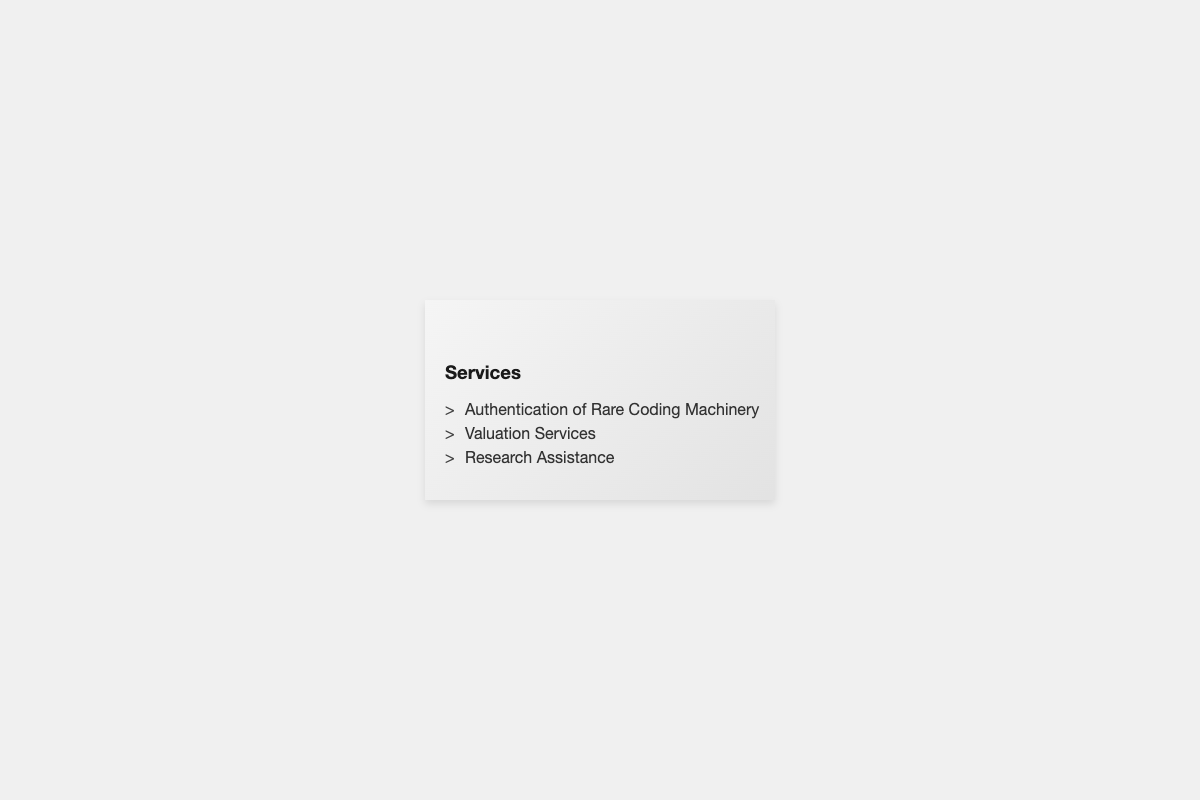What is the name of the specialist? The document provides the name "Alexis Morgan" as the tech historian and authentication specialist.
Answer: Alexis Morgan What services are offered? The front side of the business card lists three services: authentication of rare coding machinery, valuation services, and research assistance.
Answer: Authentication of Rare Coding Machinery, Valuation Services, Research Assistance What is the email address? The contact information on the back includes the email address for reaching Alexis Morgan, which is displayed.
Answer: amorgan@retrotechauthentica.com What is the contact phone number? The document clearly lists the phone number for contacting the authentication specialist, which is stated in the contact info section.
Answer: +1 555-123-4567 Where is the business located? The address provided in the document indicates where RetroTech Authentica is situated, which can be found in the contact information.
Answer: 123 Vintage Lane, Silicon Valley, CA 94025 What is the website URL? The back of the business card includes the website address for RetroTech Authentica, which is given specifically in the contact info.
Answer: www.retrotechauthentica.com What type of business card is this? The document is identified as a business card tailored for a tech historian and authentication specialist, featuring dual-texture design.
Answer: Dual-texture business card 